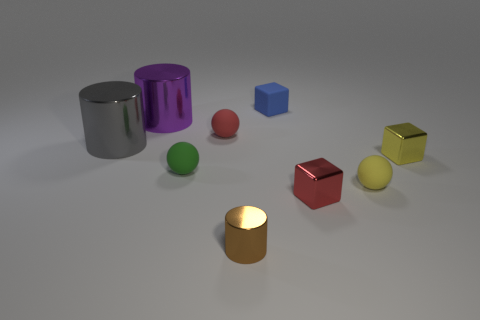What is the color of the other big cylinder that is made of the same material as the large purple cylinder?
Keep it short and to the point. Gray. Is the size of the blue block the same as the red object right of the blue matte cube?
Provide a succinct answer. Yes. What size is the thing that is in front of the red object that is in front of the matte thing on the right side of the red metal thing?
Give a very brief answer. Small. How many metallic objects are either yellow spheres or cylinders?
Provide a short and direct response. 3. There is a tiny sphere that is behind the tiny yellow metallic cube; what is its color?
Ensure brevity in your answer.  Red. The brown metal thing that is the same size as the blue cube is what shape?
Keep it short and to the point. Cylinder. There is a tiny matte block; is it the same color as the big thing that is left of the large purple cylinder?
Ensure brevity in your answer.  No. What number of things are either tiny yellow objects that are in front of the green ball or small blocks in front of the large gray metallic cylinder?
Provide a short and direct response. 3. There is a red sphere that is the same size as the green thing; what is it made of?
Your answer should be compact. Rubber. What number of other things are made of the same material as the gray thing?
Offer a terse response. 4. 